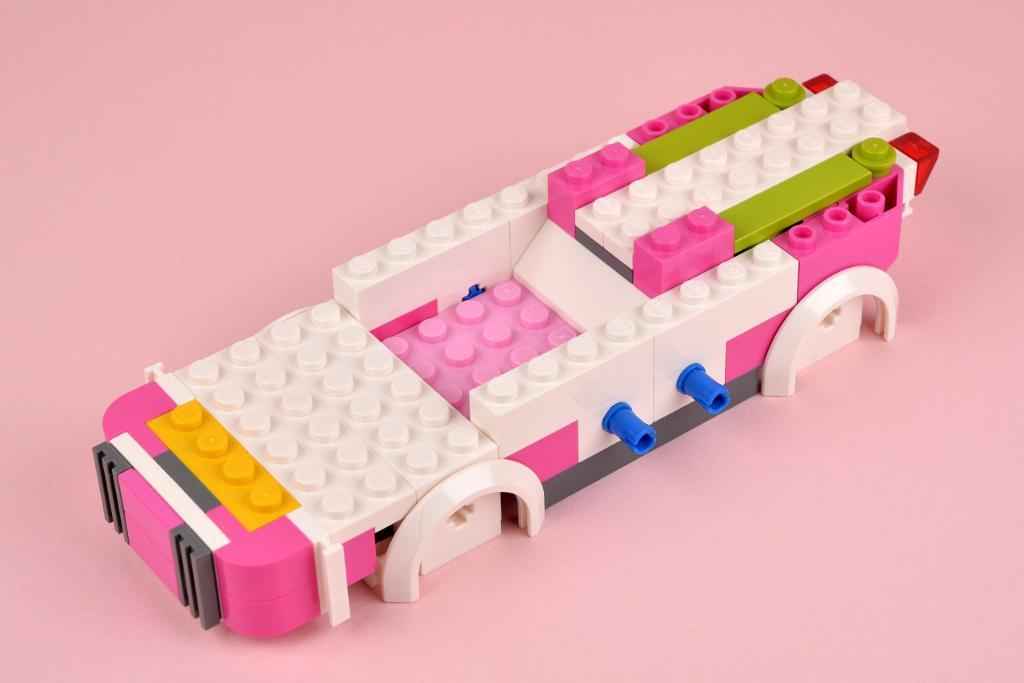What type of toy is shown in the image? There are Lego building blocks in the image. What can be done with these blocks? These blocks can be used to build various structures and models. What is the color scheme of the blocks in the image? The colors of the blocks in the image can vary, as Lego blocks come in a wide range of colors. How many geese are present in the image? There are no geese present in the image; it features Lego building blocks. What type of bird is perched on the wren in the image? There is no wren or bird present in the image; it features Lego building blocks. 